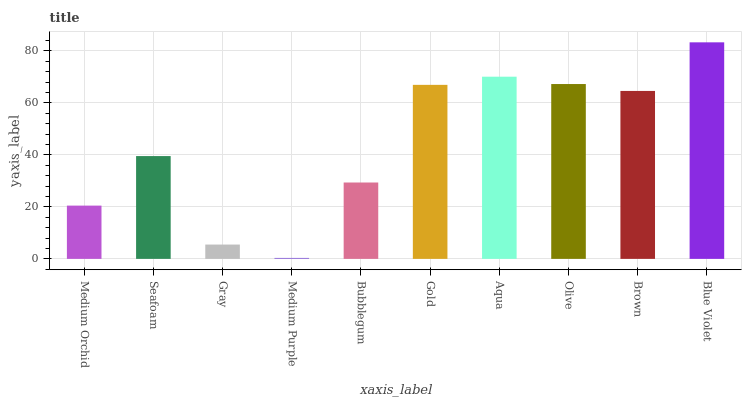Is Medium Purple the minimum?
Answer yes or no. Yes. Is Blue Violet the maximum?
Answer yes or no. Yes. Is Seafoam the minimum?
Answer yes or no. No. Is Seafoam the maximum?
Answer yes or no. No. Is Seafoam greater than Medium Orchid?
Answer yes or no. Yes. Is Medium Orchid less than Seafoam?
Answer yes or no. Yes. Is Medium Orchid greater than Seafoam?
Answer yes or no. No. Is Seafoam less than Medium Orchid?
Answer yes or no. No. Is Brown the high median?
Answer yes or no. Yes. Is Seafoam the low median?
Answer yes or no. Yes. Is Aqua the high median?
Answer yes or no. No. Is Gray the low median?
Answer yes or no. No. 